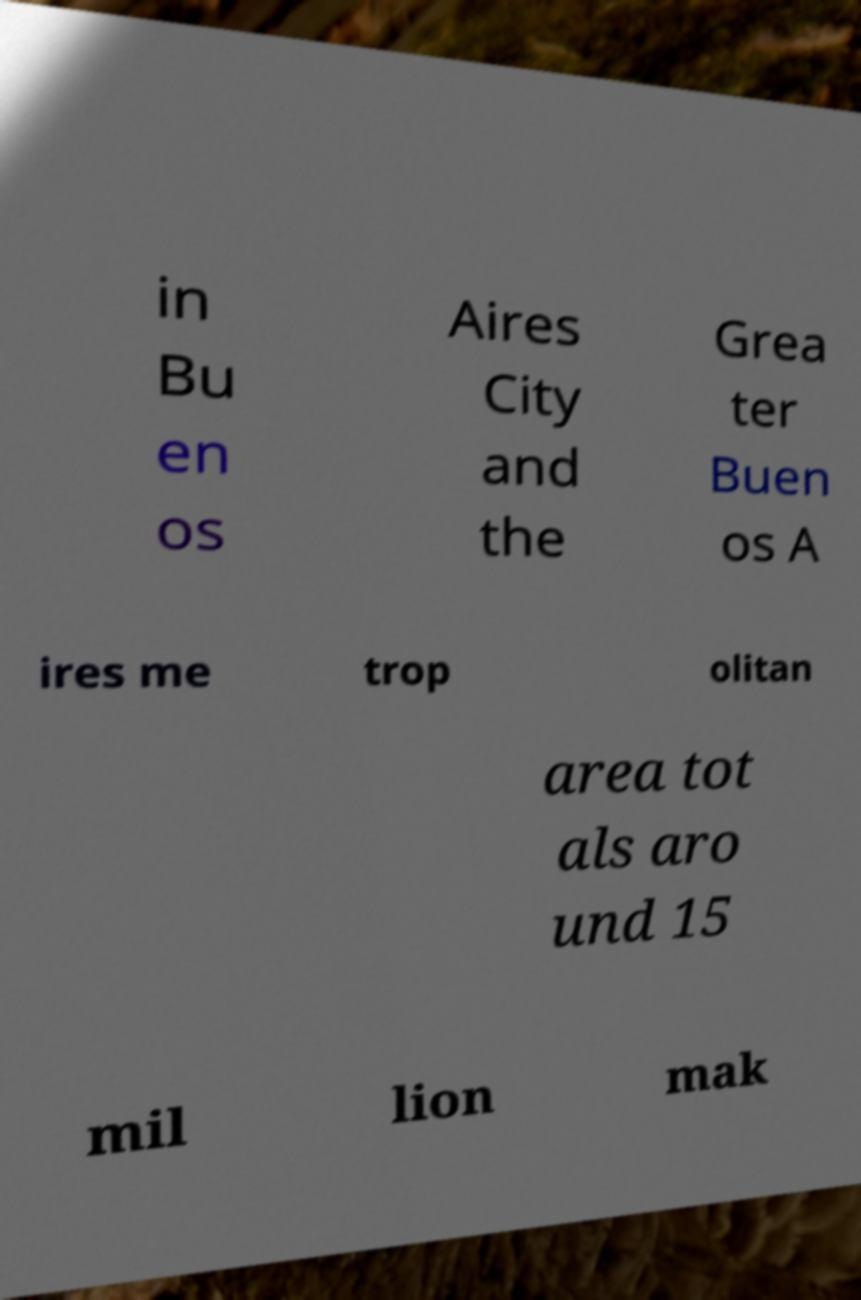For documentation purposes, I need the text within this image transcribed. Could you provide that? in Bu en os Aires City and the Grea ter Buen os A ires me trop olitan area tot als aro und 15 mil lion mak 